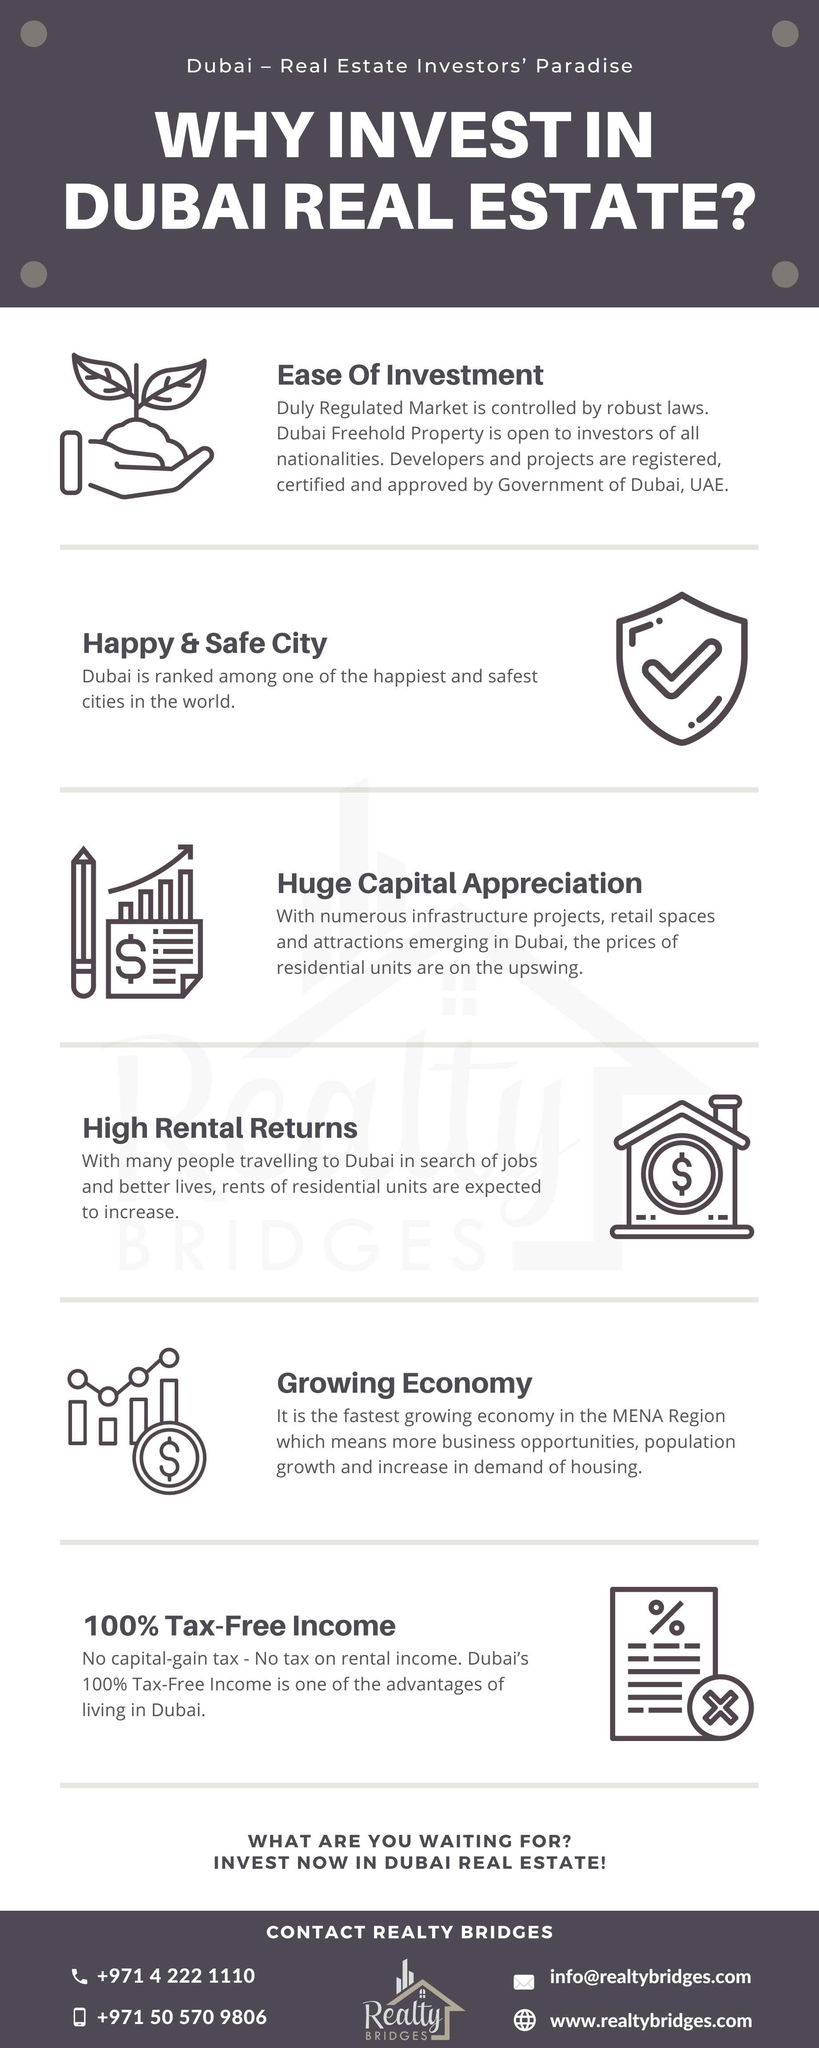Give some essential details in this illustration. The mobile number given is +971 50 570 9806. The email address provided is [info@realtybridges.com](mailto:info@realtybridges.com). 